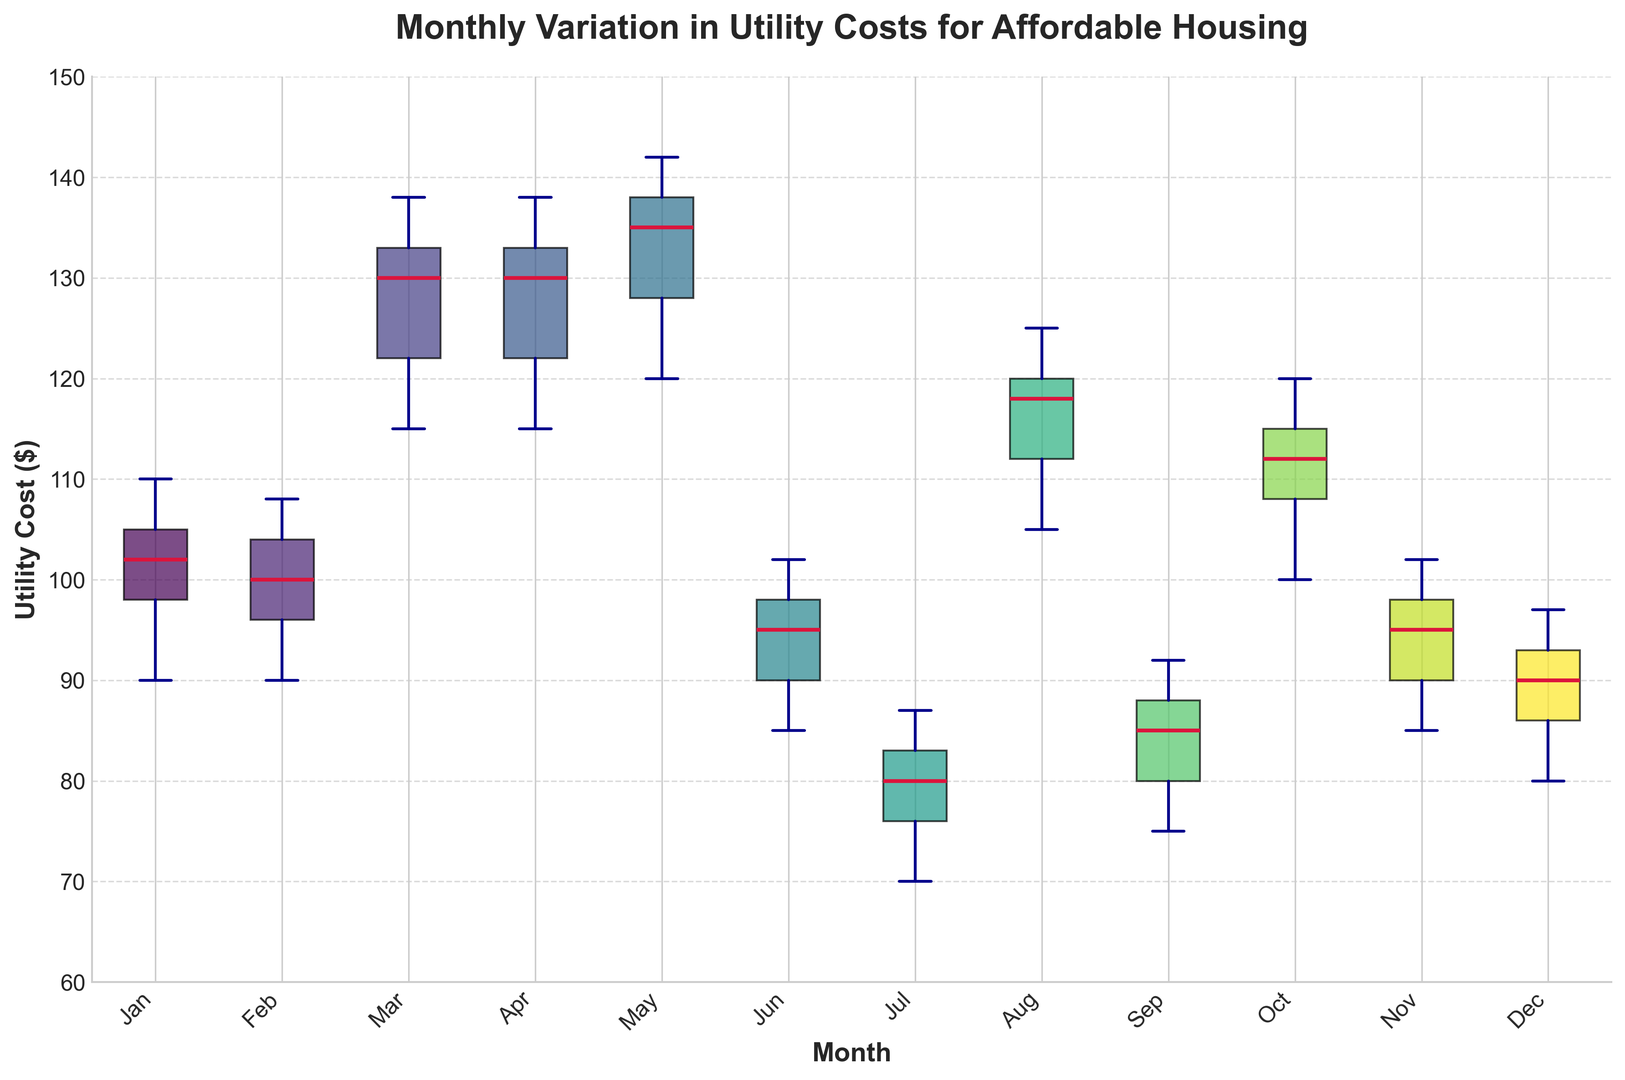What is the median utility cost in January? In the box plot, the median is marked by the line inside the box for January.
Answer: 135 Which month has the highest median utility cost? By comparing the line inside each box for all months, we can see which one is the highest.
Answer: January How does the utility cost range for June compare to that for January? The box plot's range is determined by the ends of the whiskers. For January, the whiskers are approximately at 120 and 142. For June, the whiskers are approximately at 70 and 87.
Answer: January has a higher range In which month is the utility cost variability highest? The variability can be inferred from the length of the box and whiskers. The longer they are, the higher the variability.
Answer: January Which months have the lowest median utility costs? By looking at the lines inside the boxes and identifying the lowest positions, we can determine the months with the lowest medians.
Answer: May and June How do the utility costs for July compare visually with those of August? The height of the box and whiskers should be compared. Both median lines are similar, but the range for August is slightly higher.
Answer: August has a slightly higher range Estimate the interquartile range (IQR) for February. The IQR can be estimated by measuring the distance between the top and bottom of the box for February.
Answer: Approximately 16 (top is ~135, bottom is ~119) What is the general trend in the median utility costs from January to December? Observing the lines inside the boxes from left (January) to right (December), note how they change direction.
Answer: Decrease from January to June, then increase to December Which months have similar median utility costs? By finding the months where the lines inside the boxes are close to each other.
Answer: July and October 